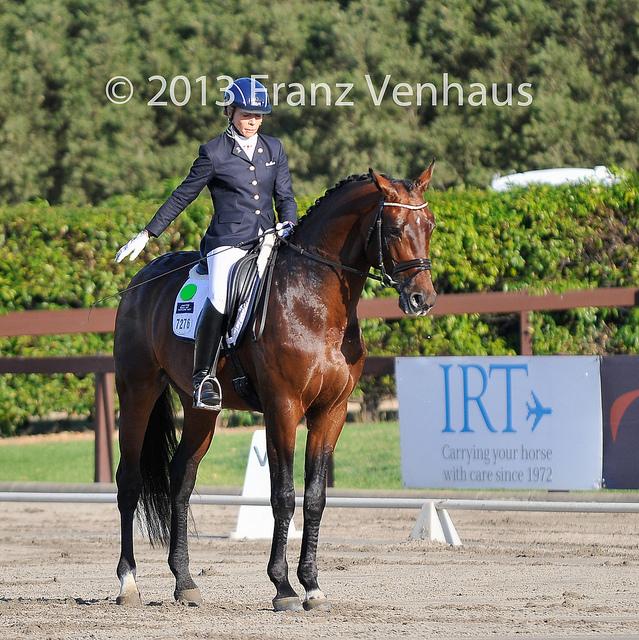Is the jockey encouraging the horse?
Quick response, please. Yes. What is written on the sign?
Quick response, please. Irt. What color is the fence?
Short answer required. Brown. Is there a plane on the IRT sign?
Answer briefly. Yes. Who owns this picture?
Be succinct. Franz venhaus. What color is the letters in the background?
Write a very short answer. Blue. What is the copyright year of this photo?
Short answer required. 2013. Is a man or a woman riding the horse?
Keep it brief. Woman. 